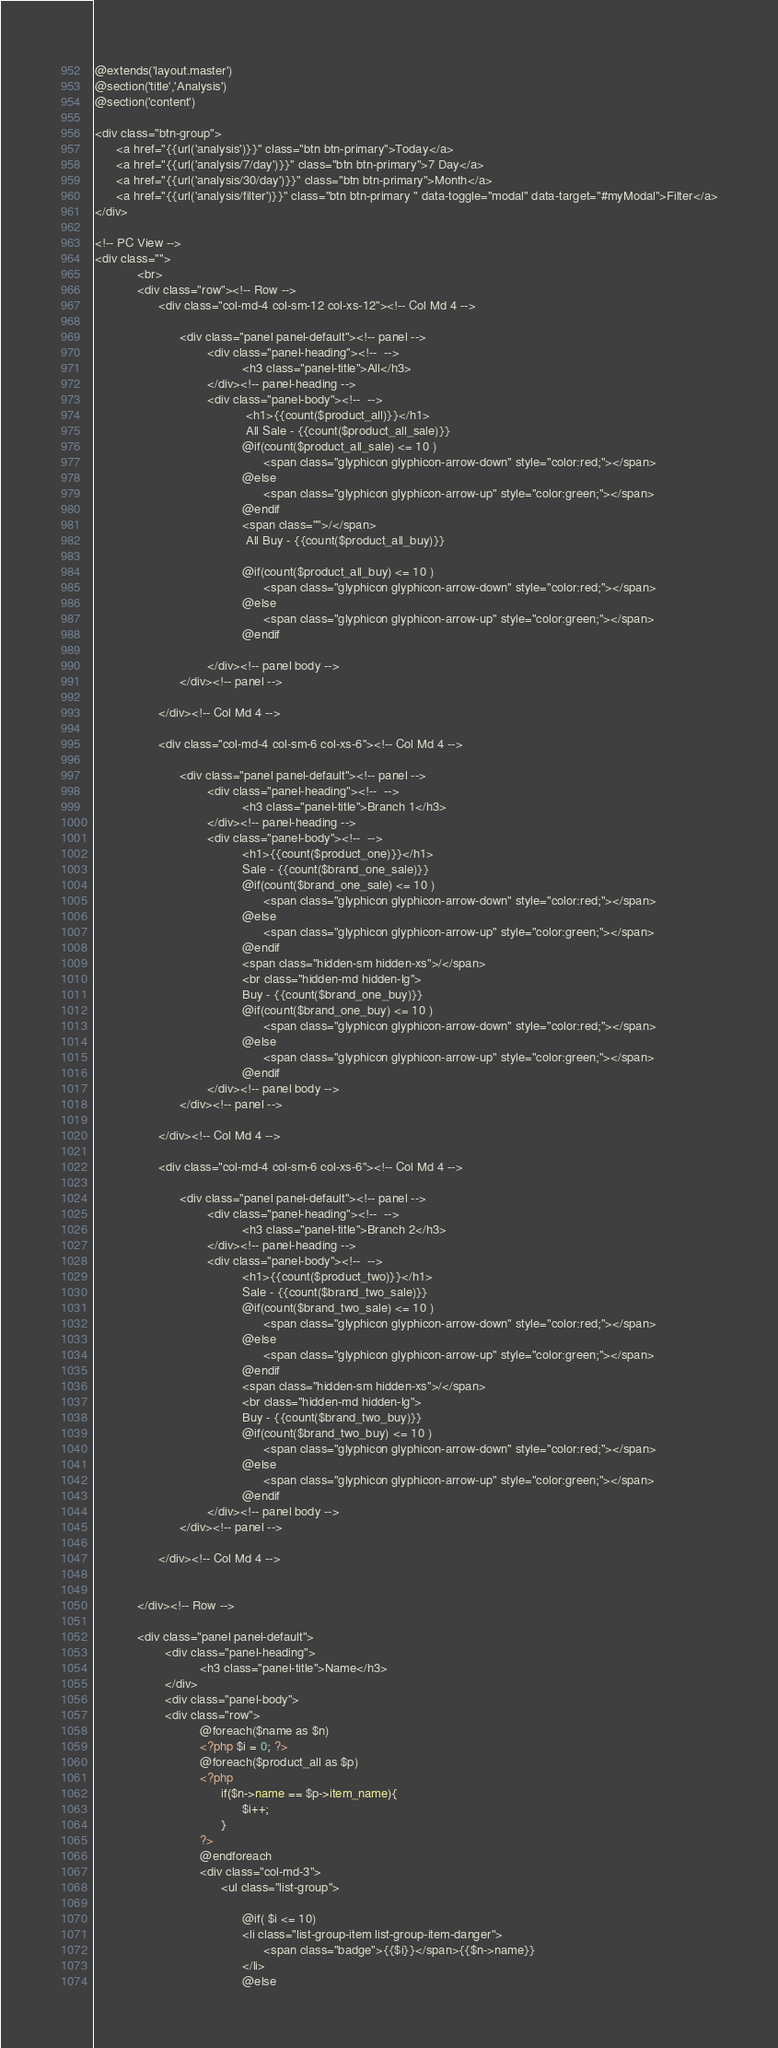Convert code to text. <code><loc_0><loc_0><loc_500><loc_500><_PHP_>@extends('layout.master')
@section('title','Analysis')
@section('content')

<div class="btn-group">
      <a href="{{url('analysis')}}" class="btn btn-primary">Today</a>
      <a href="{{url('analysis/7/day')}}" class="btn btn-primary">7 Day</a>
      <a href="{{url('analysis/30/day')}}" class="btn btn-primary">Month</a>
      <a href="{{url('analysis/filter')}}" class="btn btn-primary " data-toggle="modal" data-target="#myModal">Filter</a>
</div>

<!-- PC View -->
<div class="">
            <br>
            <div class="row"><!-- Row -->
                  <div class="col-md-4 col-sm-12 col-xs-12"><!-- Col Md 4 -->
                        
                        <div class="panel panel-default"><!-- panel -->
                                <div class="panel-heading"><!--  -->
                                          <h3 class="panel-title">All</h3>
                                </div><!-- panel-heading -->
                                <div class="panel-body"><!--  -->
                                           <h1>{{count($product_all)}}</h1>
                                           All Sale - {{count($product_all_sale)}}
                                          @if(count($product_all_sale) <= 10 )
                                                <span class="glyphicon glyphicon-arrow-down" style="color:red;"></span>
                                          @else
                                                <span class="glyphicon glyphicon-arrow-up" style="color:green;"></span>
                                          @endif
                                          <span class="">/</span>
                                           All Buy - {{count($product_all_buy)}}

                                          @if(count($product_all_buy) <= 10 )
                                                <span class="glyphicon glyphicon-arrow-down" style="color:red;"></span>
                                          @else
                                                <span class="glyphicon glyphicon-arrow-up" style="color:green;"></span>
                                          @endif

                                </div><!-- panel body -->
                        </div><!-- panel -->
                        
                  </div><!-- Col Md 4 -->

                  <div class="col-md-4 col-sm-6 col-xs-6"><!-- Col Md 4 -->
                        
                        <div class="panel panel-default"><!-- panel -->
                                <div class="panel-heading"><!--  -->
                                          <h3 class="panel-title">Branch 1</h3>
                                </div><!-- panel-heading -->
                                <div class="panel-body"><!--  -->
                                          <h1>{{count($product_one)}}</h1>
                                          Sale - {{count($brand_one_sale)}} 
                                          @if(count($brand_one_sale) <= 10 )
                                                <span class="glyphicon glyphicon-arrow-down" style="color:red;"></span>
                                          @else
                                                <span class="glyphicon glyphicon-arrow-up" style="color:green;"></span>
                                          @endif
                                          <span class="hidden-sm hidden-xs">/</span>
                                          <br class="hidden-md hidden-lg">
                                          Buy - {{count($brand_one_buy)}}
                                          @if(count($brand_one_buy) <= 10 )
                                                <span class="glyphicon glyphicon-arrow-down" style="color:red;"></span>
                                          @else
                                                <span class="glyphicon glyphicon-arrow-up" style="color:green;"></span>
                                          @endif
                                </div><!-- panel body -->
                        </div><!-- panel -->
                        
                  </div><!-- Col Md 4 -->

                  <div class="col-md-4 col-sm-6 col-xs-6"><!-- Col Md 4 -->
                        
                        <div class="panel panel-default"><!-- panel -->
                                <div class="panel-heading"><!--  -->
                                          <h3 class="panel-title">Branch 2</h3>
                                </div><!-- panel-heading -->
                                <div class="panel-body"><!--  -->
                                          <h1>{{count($product_two)}}</h1>
                                          Sale - {{count($brand_two_sale)}} 
                                          @if(count($brand_two_sale) <= 10 )
                                                <span class="glyphicon glyphicon-arrow-down" style="color:red;"></span>
                                          @else
                                                <span class="glyphicon glyphicon-arrow-up" style="color:green;"></span>
                                          @endif
                                          <span class="hidden-sm hidden-xs">/</span>
                                          <br class="hidden-md hidden-lg">
                                          Buy - {{count($brand_two_buy)}} 
                                          @if(count($brand_two_buy) <= 10 )
                                                <span class="glyphicon glyphicon-arrow-down" style="color:red;"></span>
                                          @else
                                                <span class="glyphicon glyphicon-arrow-up" style="color:green;"></span>
                                          @endif
                                </div><!-- panel body -->
                        </div><!-- panel -->
                        
                  </div><!-- Col Md 4 -->

                  
            </div><!-- Row -->

            <div class="panel panel-default">
                    <div class="panel-heading">
                              <h3 class="panel-title">Name</h3>
                    </div>
                    <div class="panel-body">
                    <div class="row">
                              @foreach($name as $n)
                              <?php $i = 0; ?>
                              @foreach($product_all as $p)
                              <?php
                                    if($n->name == $p->item_name){
                                          $i++;
                                    }
                              ?>
                              @endforeach
                              <div class="col-md-3">
                                    <ul class="list-group">
                                          
                                          @if( $i <= 10)
                                          <li class="list-group-item list-group-item-danger">
                                                <span class="badge">{{$i}}</span>{{$n->name}}
                                          </li>
                                          @else</code> 